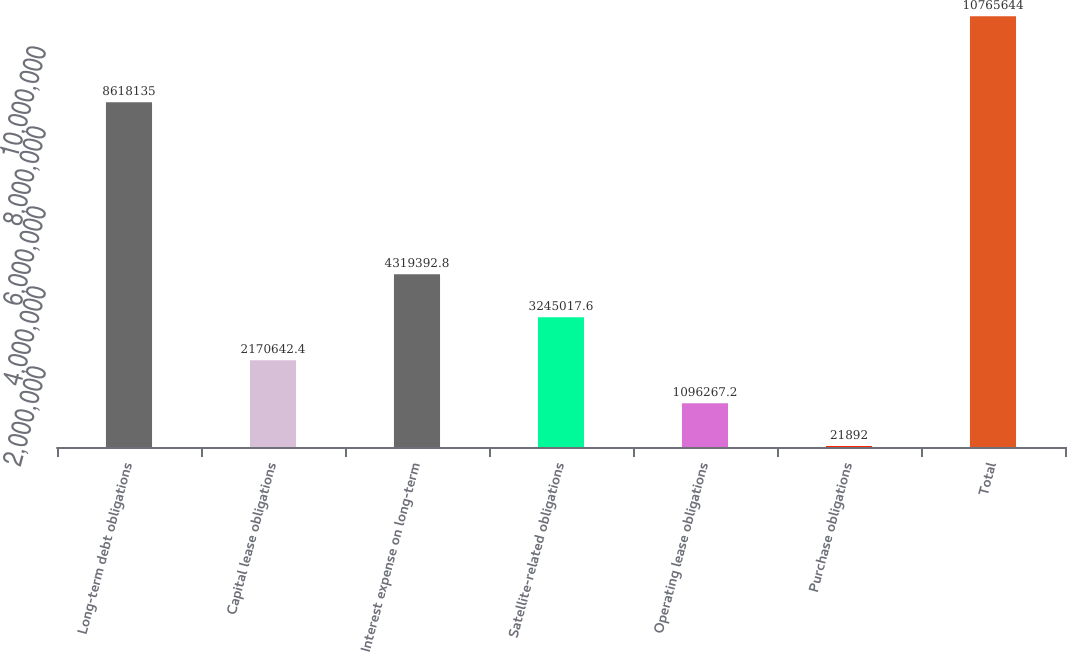Convert chart to OTSL. <chart><loc_0><loc_0><loc_500><loc_500><bar_chart><fcel>Long-term debt obligations<fcel>Capital lease obligations<fcel>Interest expense on long-term<fcel>Satellite-related obligations<fcel>Operating lease obligations<fcel>Purchase obligations<fcel>Total<nl><fcel>8.61814e+06<fcel>2.17064e+06<fcel>4.31939e+06<fcel>3.24502e+06<fcel>1.09627e+06<fcel>21892<fcel>1.07656e+07<nl></chart> 